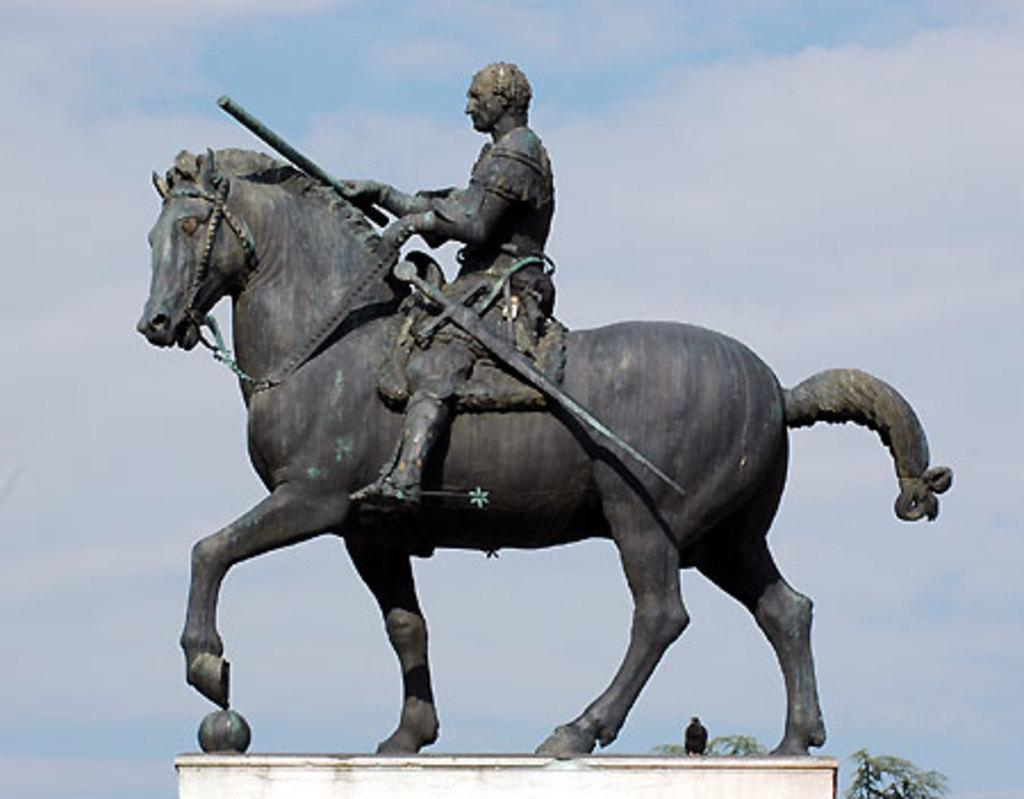What is the main subject of the image? The main subject of the image is a statue of a man on a horse. How would you describe the sky in the image? The sky in the image is clear and has some clouds in the background. What attempt is the man on the horse making in the image? There is no attempt being made by the man on the horse in the image, as it is a statue. Is the man on the horse playing baseball in the image? No, the man on the horse is not playing baseball in the image, as it is a statue and not engaged in any activity. 